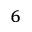<formula> <loc_0><loc_0><loc_500><loc_500>_ { 6 }</formula> 